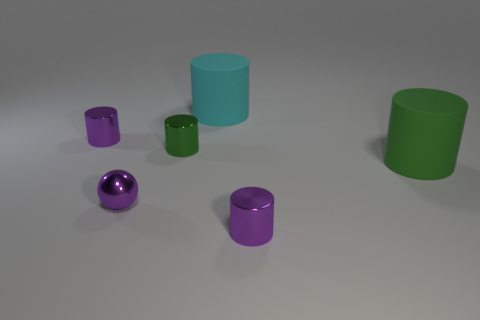Subtract 1 cylinders. How many cylinders are left? 4 Subtract all large cyan matte cylinders. How many cylinders are left? 4 Subtract all cyan cylinders. How many cylinders are left? 4 Subtract all brown cylinders. Subtract all blue balls. How many cylinders are left? 5 Add 4 big green metallic blocks. How many objects exist? 10 Subtract all spheres. How many objects are left? 5 Add 2 big matte cylinders. How many big matte cylinders are left? 4 Add 6 spheres. How many spheres exist? 7 Subtract 0 gray spheres. How many objects are left? 6 Subtract all big green metal cylinders. Subtract all large cyan rubber cylinders. How many objects are left? 5 